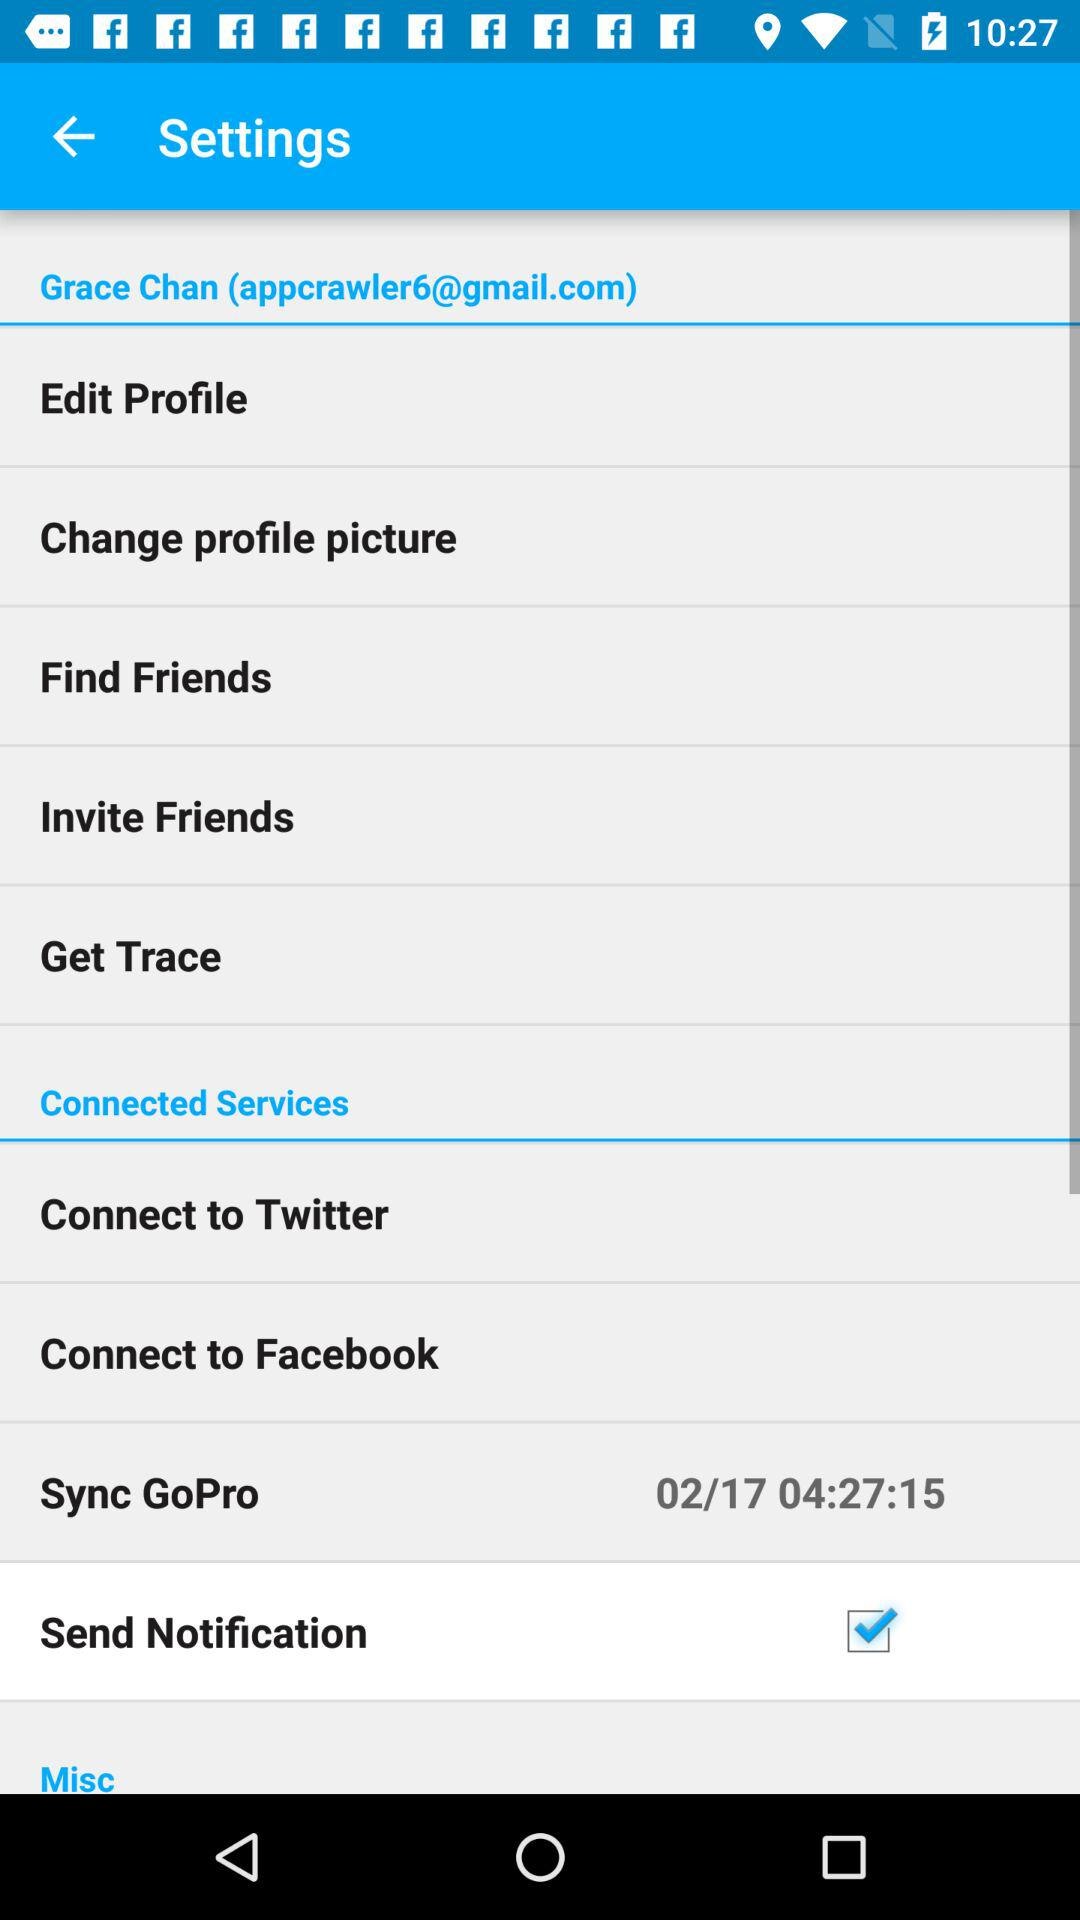What is the status of the "Send Notification"? The status of the "Send Notification" is "on". 